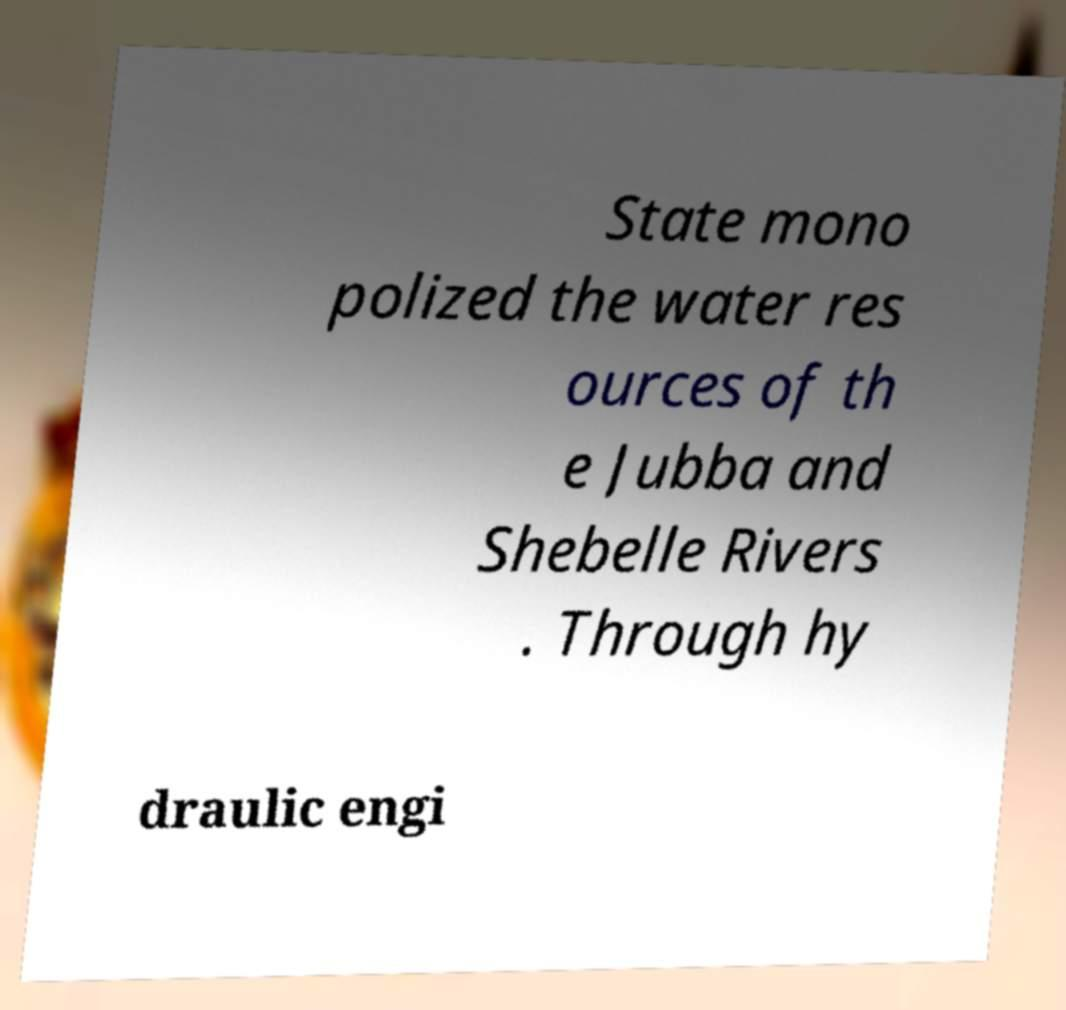I need the written content from this picture converted into text. Can you do that? State mono polized the water res ources of th e Jubba and Shebelle Rivers . Through hy draulic engi 